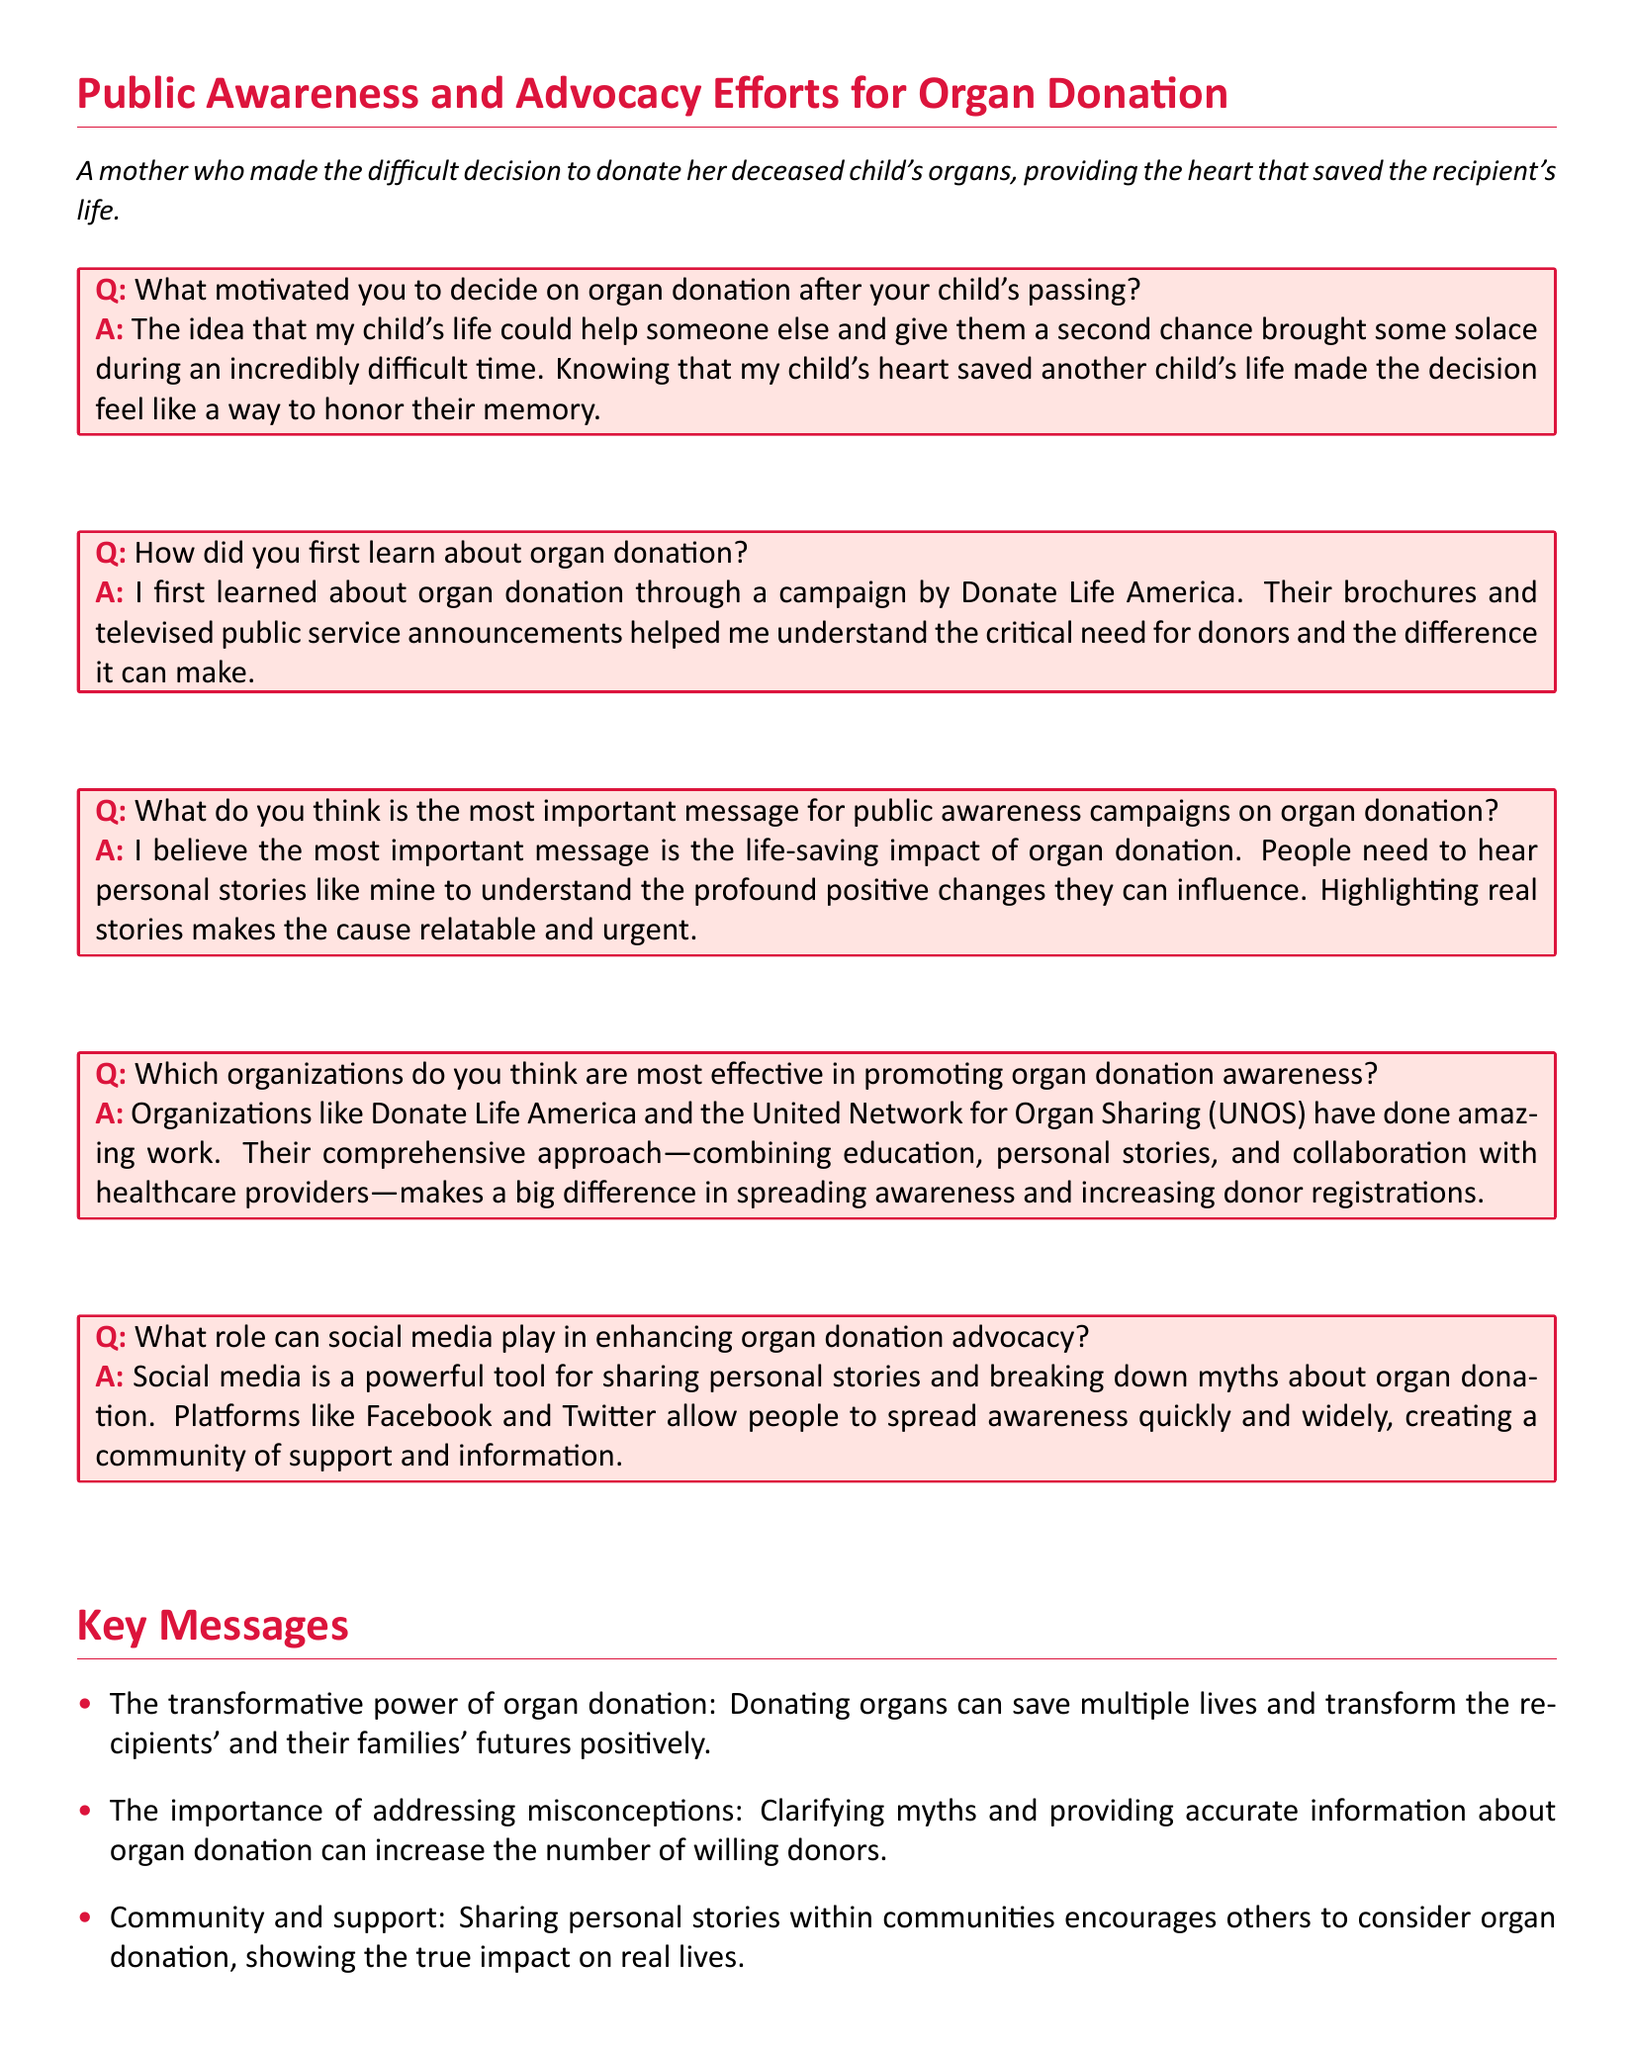What motivated the mother to donate her child's organs? The motivation came from the idea that her child's life could help someone else and give them a second chance.
Answer: A second chance How did the mother first learn about organ donation? She first learned about it through a campaign by Donate Life America which included brochures and public service announcements.
Answer: Donate Life America What does the mother believe is the most important message for organ donation awareness? She believes the most important message is the life-saving impact of organ donation.
Answer: Life-saving impact Which organizations does the mother think are most effective in promoting awareness? The mother recognizes organizations like Donate Life America and the United Network for Organ Sharing (UNOS) as effective.
Answer: Donate Life America and UNOS What tool does the mother mention as powerful for organ donation advocacy? She mentions social media as a powerful tool for sharing personal stories and breaking down myths.
Answer: Social media What key message highlights the transformation due to organ donation? The transformative power of organ donation emphasizes saving multiple lives and positively transforming futures.
Answer: Transformative power Which key message addresses misconceptions about organ donation? The importance of addressing misconceptions is a key message that clarifies myths and provides accurate information.
Answer: Addressing misconceptions What is the overall tone of the document regarding organ donation? The overall tone of the document is supportive and informative, encouraging organ donation.
Answer: Supportive and informative 